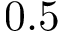Convert formula to latex. <formula><loc_0><loc_0><loc_500><loc_500>0 . 5</formula> 